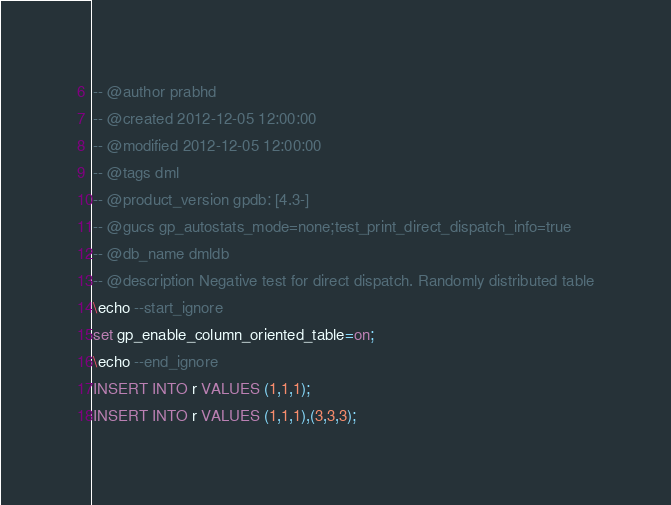<code> <loc_0><loc_0><loc_500><loc_500><_SQL_>-- @author prabhd 
-- @created 2012-12-05 12:00:00 
-- @modified 2012-12-05 12:00:00 
-- @tags dml
-- @product_version gpdb: [4.3-]
-- @gucs gp_autostats_mode=none;test_print_direct_dispatch_info=true
-- @db_name dmldb
-- @description Negative test for direct dispatch. Randomly distributed table
\echo --start_ignore
set gp_enable_column_oriented_table=on;
\echo --end_ignore
INSERT INTO r VALUES (1,1,1);
INSERT INTO r VALUES (1,1,1),(3,3,3);
</code> 